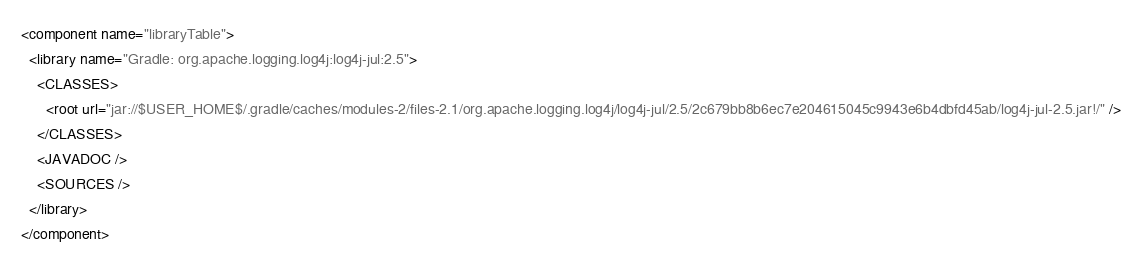<code> <loc_0><loc_0><loc_500><loc_500><_XML_><component name="libraryTable">
  <library name="Gradle: org.apache.logging.log4j:log4j-jul:2.5">
    <CLASSES>
      <root url="jar://$USER_HOME$/.gradle/caches/modules-2/files-2.1/org.apache.logging.log4j/log4j-jul/2.5/2c679bb8b6ec7e204615045c9943e6b4dbfd45ab/log4j-jul-2.5.jar!/" />
    </CLASSES>
    <JAVADOC />
    <SOURCES />
  </library>
</component></code> 